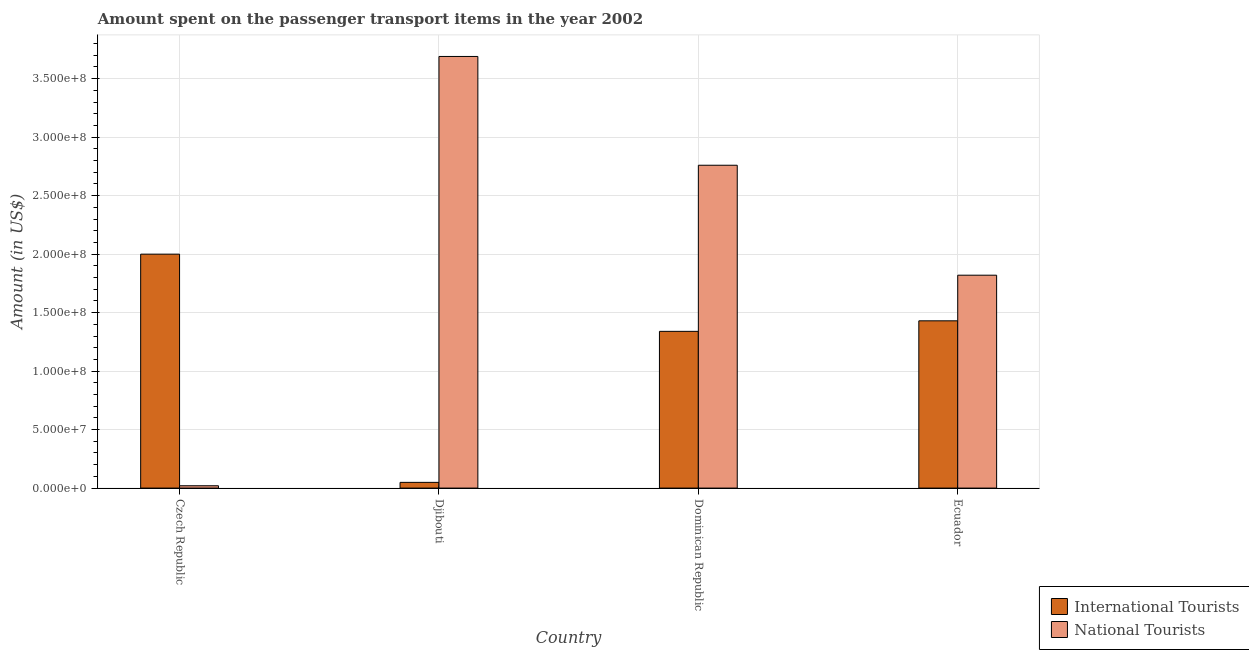How many different coloured bars are there?
Ensure brevity in your answer.  2. Are the number of bars per tick equal to the number of legend labels?
Offer a very short reply. Yes. How many bars are there on the 2nd tick from the left?
Make the answer very short. 2. What is the label of the 2nd group of bars from the left?
Provide a short and direct response. Djibouti. What is the amount spent on transport items of international tourists in Dominican Republic?
Your response must be concise. 1.34e+08. Across all countries, what is the maximum amount spent on transport items of national tourists?
Make the answer very short. 3.69e+08. Across all countries, what is the minimum amount spent on transport items of international tourists?
Offer a terse response. 4.90e+06. In which country was the amount spent on transport items of international tourists maximum?
Provide a short and direct response. Czech Republic. In which country was the amount spent on transport items of international tourists minimum?
Give a very brief answer. Djibouti. What is the total amount spent on transport items of national tourists in the graph?
Offer a very short reply. 8.29e+08. What is the difference between the amount spent on transport items of international tourists in Dominican Republic and that in Ecuador?
Your answer should be very brief. -9.00e+06. What is the difference between the amount spent on transport items of national tourists in Djibouti and the amount spent on transport items of international tourists in Czech Republic?
Provide a short and direct response. 1.69e+08. What is the average amount spent on transport items of international tourists per country?
Ensure brevity in your answer.  1.20e+08. What is the difference between the amount spent on transport items of national tourists and amount spent on transport items of international tourists in Djibouti?
Provide a short and direct response. 3.64e+08. What is the ratio of the amount spent on transport items of international tourists in Czech Republic to that in Dominican Republic?
Ensure brevity in your answer.  1.49. What is the difference between the highest and the second highest amount spent on transport items of national tourists?
Your response must be concise. 9.30e+07. What is the difference between the highest and the lowest amount spent on transport items of international tourists?
Your answer should be compact. 1.95e+08. In how many countries, is the amount spent on transport items of international tourists greater than the average amount spent on transport items of international tourists taken over all countries?
Offer a terse response. 3. What does the 2nd bar from the left in Ecuador represents?
Provide a succinct answer. National Tourists. What does the 2nd bar from the right in Djibouti represents?
Your answer should be compact. International Tourists. How many countries are there in the graph?
Your response must be concise. 4. Are the values on the major ticks of Y-axis written in scientific E-notation?
Your answer should be compact. Yes. Does the graph contain any zero values?
Your answer should be compact. No. How are the legend labels stacked?
Give a very brief answer. Vertical. What is the title of the graph?
Keep it short and to the point. Amount spent on the passenger transport items in the year 2002. Does "Adolescent fertility rate" appear as one of the legend labels in the graph?
Make the answer very short. No. What is the label or title of the X-axis?
Provide a succinct answer. Country. What is the label or title of the Y-axis?
Ensure brevity in your answer.  Amount (in US$). What is the Amount (in US$) in International Tourists in Djibouti?
Offer a terse response. 4.90e+06. What is the Amount (in US$) in National Tourists in Djibouti?
Provide a succinct answer. 3.69e+08. What is the Amount (in US$) in International Tourists in Dominican Republic?
Make the answer very short. 1.34e+08. What is the Amount (in US$) of National Tourists in Dominican Republic?
Your answer should be compact. 2.76e+08. What is the Amount (in US$) in International Tourists in Ecuador?
Make the answer very short. 1.43e+08. What is the Amount (in US$) in National Tourists in Ecuador?
Provide a succinct answer. 1.82e+08. Across all countries, what is the maximum Amount (in US$) of International Tourists?
Offer a terse response. 2.00e+08. Across all countries, what is the maximum Amount (in US$) of National Tourists?
Provide a short and direct response. 3.69e+08. Across all countries, what is the minimum Amount (in US$) in International Tourists?
Keep it short and to the point. 4.90e+06. What is the total Amount (in US$) in International Tourists in the graph?
Provide a succinct answer. 4.82e+08. What is the total Amount (in US$) in National Tourists in the graph?
Offer a very short reply. 8.29e+08. What is the difference between the Amount (in US$) in International Tourists in Czech Republic and that in Djibouti?
Your answer should be very brief. 1.95e+08. What is the difference between the Amount (in US$) in National Tourists in Czech Republic and that in Djibouti?
Give a very brief answer. -3.67e+08. What is the difference between the Amount (in US$) in International Tourists in Czech Republic and that in Dominican Republic?
Give a very brief answer. 6.60e+07. What is the difference between the Amount (in US$) of National Tourists in Czech Republic and that in Dominican Republic?
Offer a terse response. -2.74e+08. What is the difference between the Amount (in US$) of International Tourists in Czech Republic and that in Ecuador?
Keep it short and to the point. 5.70e+07. What is the difference between the Amount (in US$) of National Tourists in Czech Republic and that in Ecuador?
Offer a terse response. -1.80e+08. What is the difference between the Amount (in US$) in International Tourists in Djibouti and that in Dominican Republic?
Your answer should be very brief. -1.29e+08. What is the difference between the Amount (in US$) in National Tourists in Djibouti and that in Dominican Republic?
Ensure brevity in your answer.  9.30e+07. What is the difference between the Amount (in US$) in International Tourists in Djibouti and that in Ecuador?
Keep it short and to the point. -1.38e+08. What is the difference between the Amount (in US$) in National Tourists in Djibouti and that in Ecuador?
Keep it short and to the point. 1.87e+08. What is the difference between the Amount (in US$) in International Tourists in Dominican Republic and that in Ecuador?
Ensure brevity in your answer.  -9.00e+06. What is the difference between the Amount (in US$) of National Tourists in Dominican Republic and that in Ecuador?
Your answer should be compact. 9.40e+07. What is the difference between the Amount (in US$) of International Tourists in Czech Republic and the Amount (in US$) of National Tourists in Djibouti?
Provide a short and direct response. -1.69e+08. What is the difference between the Amount (in US$) of International Tourists in Czech Republic and the Amount (in US$) of National Tourists in Dominican Republic?
Your answer should be very brief. -7.60e+07. What is the difference between the Amount (in US$) in International Tourists in Czech Republic and the Amount (in US$) in National Tourists in Ecuador?
Ensure brevity in your answer.  1.80e+07. What is the difference between the Amount (in US$) in International Tourists in Djibouti and the Amount (in US$) in National Tourists in Dominican Republic?
Offer a very short reply. -2.71e+08. What is the difference between the Amount (in US$) in International Tourists in Djibouti and the Amount (in US$) in National Tourists in Ecuador?
Your answer should be very brief. -1.77e+08. What is the difference between the Amount (in US$) in International Tourists in Dominican Republic and the Amount (in US$) in National Tourists in Ecuador?
Ensure brevity in your answer.  -4.80e+07. What is the average Amount (in US$) in International Tourists per country?
Make the answer very short. 1.20e+08. What is the average Amount (in US$) in National Tourists per country?
Make the answer very short. 2.07e+08. What is the difference between the Amount (in US$) in International Tourists and Amount (in US$) in National Tourists in Czech Republic?
Ensure brevity in your answer.  1.98e+08. What is the difference between the Amount (in US$) in International Tourists and Amount (in US$) in National Tourists in Djibouti?
Your response must be concise. -3.64e+08. What is the difference between the Amount (in US$) of International Tourists and Amount (in US$) of National Tourists in Dominican Republic?
Ensure brevity in your answer.  -1.42e+08. What is the difference between the Amount (in US$) in International Tourists and Amount (in US$) in National Tourists in Ecuador?
Make the answer very short. -3.90e+07. What is the ratio of the Amount (in US$) of International Tourists in Czech Republic to that in Djibouti?
Keep it short and to the point. 40.82. What is the ratio of the Amount (in US$) of National Tourists in Czech Republic to that in Djibouti?
Offer a very short reply. 0.01. What is the ratio of the Amount (in US$) in International Tourists in Czech Republic to that in Dominican Republic?
Give a very brief answer. 1.49. What is the ratio of the Amount (in US$) of National Tourists in Czech Republic to that in Dominican Republic?
Make the answer very short. 0.01. What is the ratio of the Amount (in US$) in International Tourists in Czech Republic to that in Ecuador?
Provide a short and direct response. 1.4. What is the ratio of the Amount (in US$) in National Tourists in Czech Republic to that in Ecuador?
Your answer should be compact. 0.01. What is the ratio of the Amount (in US$) of International Tourists in Djibouti to that in Dominican Republic?
Your answer should be very brief. 0.04. What is the ratio of the Amount (in US$) in National Tourists in Djibouti to that in Dominican Republic?
Ensure brevity in your answer.  1.34. What is the ratio of the Amount (in US$) of International Tourists in Djibouti to that in Ecuador?
Provide a short and direct response. 0.03. What is the ratio of the Amount (in US$) of National Tourists in Djibouti to that in Ecuador?
Offer a very short reply. 2.03. What is the ratio of the Amount (in US$) of International Tourists in Dominican Republic to that in Ecuador?
Make the answer very short. 0.94. What is the ratio of the Amount (in US$) of National Tourists in Dominican Republic to that in Ecuador?
Your answer should be compact. 1.52. What is the difference between the highest and the second highest Amount (in US$) of International Tourists?
Your answer should be very brief. 5.70e+07. What is the difference between the highest and the second highest Amount (in US$) in National Tourists?
Give a very brief answer. 9.30e+07. What is the difference between the highest and the lowest Amount (in US$) in International Tourists?
Give a very brief answer. 1.95e+08. What is the difference between the highest and the lowest Amount (in US$) of National Tourists?
Offer a very short reply. 3.67e+08. 